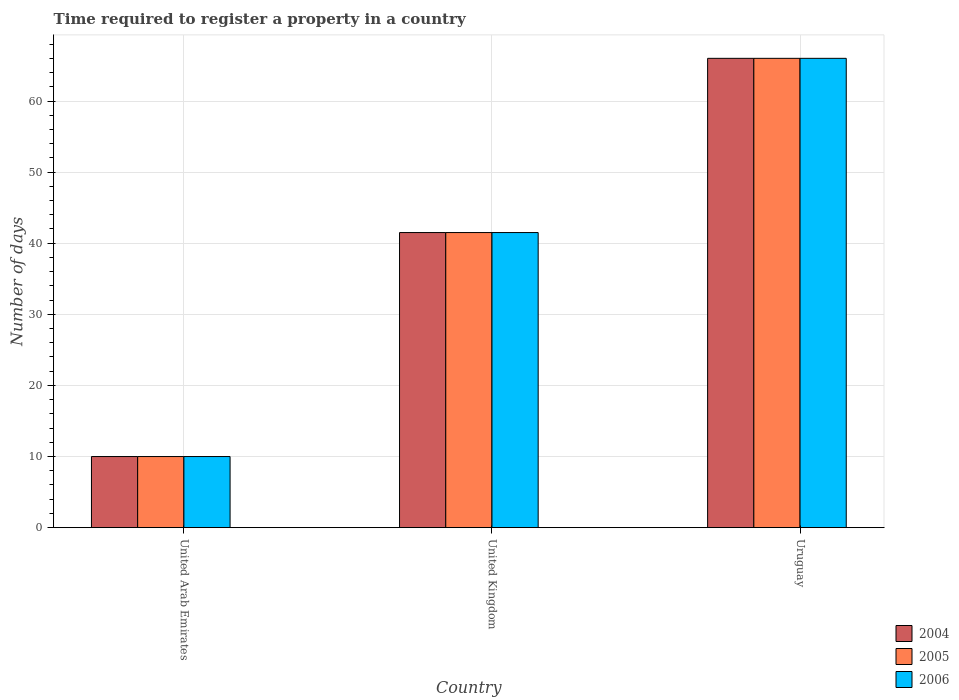How many groups of bars are there?
Ensure brevity in your answer.  3. Are the number of bars on each tick of the X-axis equal?
Provide a succinct answer. Yes. How many bars are there on the 3rd tick from the right?
Provide a succinct answer. 3. What is the label of the 1st group of bars from the left?
Your answer should be very brief. United Arab Emirates. What is the number of days required to register a property in 2006 in United Arab Emirates?
Provide a short and direct response. 10. Across all countries, what is the maximum number of days required to register a property in 2005?
Make the answer very short. 66. In which country was the number of days required to register a property in 2006 maximum?
Your answer should be compact. Uruguay. In which country was the number of days required to register a property in 2004 minimum?
Your response must be concise. United Arab Emirates. What is the total number of days required to register a property in 2004 in the graph?
Your answer should be compact. 117.5. What is the difference between the number of days required to register a property in 2004 in United Kingdom and that in Uruguay?
Your answer should be very brief. -24.5. What is the difference between the number of days required to register a property in 2004 in United Arab Emirates and the number of days required to register a property in 2006 in Uruguay?
Your answer should be compact. -56. What is the average number of days required to register a property in 2004 per country?
Keep it short and to the point. 39.17. What is the difference between the number of days required to register a property of/in 2006 and number of days required to register a property of/in 2005 in United Arab Emirates?
Provide a short and direct response. 0. In how many countries, is the number of days required to register a property in 2005 greater than 34 days?
Ensure brevity in your answer.  2. What is the ratio of the number of days required to register a property in 2004 in United Arab Emirates to that in Uruguay?
Give a very brief answer. 0.15. Is the number of days required to register a property in 2005 in United Arab Emirates less than that in United Kingdom?
Offer a terse response. Yes. What is the difference between the highest and the second highest number of days required to register a property in 2006?
Give a very brief answer. -24.5. What is the difference between the highest and the lowest number of days required to register a property in 2004?
Offer a terse response. 56. In how many countries, is the number of days required to register a property in 2004 greater than the average number of days required to register a property in 2004 taken over all countries?
Keep it short and to the point. 2. What does the 2nd bar from the right in United Arab Emirates represents?
Provide a succinct answer. 2005. Is it the case that in every country, the sum of the number of days required to register a property in 2004 and number of days required to register a property in 2005 is greater than the number of days required to register a property in 2006?
Provide a short and direct response. Yes. How many bars are there?
Provide a succinct answer. 9. What is the difference between two consecutive major ticks on the Y-axis?
Provide a short and direct response. 10. Does the graph contain grids?
Your answer should be compact. Yes. How many legend labels are there?
Your answer should be very brief. 3. How are the legend labels stacked?
Offer a very short reply. Vertical. What is the title of the graph?
Keep it short and to the point. Time required to register a property in a country. What is the label or title of the X-axis?
Ensure brevity in your answer.  Country. What is the label or title of the Y-axis?
Ensure brevity in your answer.  Number of days. What is the Number of days in 2004 in United Kingdom?
Give a very brief answer. 41.5. What is the Number of days of 2005 in United Kingdom?
Provide a short and direct response. 41.5. What is the Number of days in 2006 in United Kingdom?
Ensure brevity in your answer.  41.5. What is the Number of days in 2004 in Uruguay?
Provide a succinct answer. 66. What is the Number of days of 2005 in Uruguay?
Make the answer very short. 66. Across all countries, what is the maximum Number of days in 2005?
Offer a very short reply. 66. Across all countries, what is the minimum Number of days of 2006?
Give a very brief answer. 10. What is the total Number of days in 2004 in the graph?
Make the answer very short. 117.5. What is the total Number of days in 2005 in the graph?
Your response must be concise. 117.5. What is the total Number of days in 2006 in the graph?
Offer a terse response. 117.5. What is the difference between the Number of days of 2004 in United Arab Emirates and that in United Kingdom?
Your answer should be compact. -31.5. What is the difference between the Number of days of 2005 in United Arab Emirates and that in United Kingdom?
Your response must be concise. -31.5. What is the difference between the Number of days of 2006 in United Arab Emirates and that in United Kingdom?
Give a very brief answer. -31.5. What is the difference between the Number of days of 2004 in United Arab Emirates and that in Uruguay?
Offer a very short reply. -56. What is the difference between the Number of days in 2005 in United Arab Emirates and that in Uruguay?
Make the answer very short. -56. What is the difference between the Number of days of 2006 in United Arab Emirates and that in Uruguay?
Provide a short and direct response. -56. What is the difference between the Number of days in 2004 in United Kingdom and that in Uruguay?
Make the answer very short. -24.5. What is the difference between the Number of days of 2005 in United Kingdom and that in Uruguay?
Your answer should be compact. -24.5. What is the difference between the Number of days of 2006 in United Kingdom and that in Uruguay?
Provide a short and direct response. -24.5. What is the difference between the Number of days of 2004 in United Arab Emirates and the Number of days of 2005 in United Kingdom?
Make the answer very short. -31.5. What is the difference between the Number of days of 2004 in United Arab Emirates and the Number of days of 2006 in United Kingdom?
Offer a terse response. -31.5. What is the difference between the Number of days in 2005 in United Arab Emirates and the Number of days in 2006 in United Kingdom?
Your answer should be very brief. -31.5. What is the difference between the Number of days of 2004 in United Arab Emirates and the Number of days of 2005 in Uruguay?
Your response must be concise. -56. What is the difference between the Number of days of 2004 in United Arab Emirates and the Number of days of 2006 in Uruguay?
Offer a very short reply. -56. What is the difference between the Number of days in 2005 in United Arab Emirates and the Number of days in 2006 in Uruguay?
Give a very brief answer. -56. What is the difference between the Number of days of 2004 in United Kingdom and the Number of days of 2005 in Uruguay?
Provide a succinct answer. -24.5. What is the difference between the Number of days of 2004 in United Kingdom and the Number of days of 2006 in Uruguay?
Your answer should be very brief. -24.5. What is the difference between the Number of days of 2005 in United Kingdom and the Number of days of 2006 in Uruguay?
Offer a terse response. -24.5. What is the average Number of days in 2004 per country?
Offer a terse response. 39.17. What is the average Number of days in 2005 per country?
Your answer should be compact. 39.17. What is the average Number of days in 2006 per country?
Your response must be concise. 39.17. What is the difference between the Number of days of 2005 and Number of days of 2006 in United Arab Emirates?
Your answer should be very brief. 0. What is the difference between the Number of days of 2004 and Number of days of 2006 in United Kingdom?
Provide a succinct answer. 0. What is the difference between the Number of days in 2004 and Number of days in 2005 in Uruguay?
Keep it short and to the point. 0. What is the difference between the Number of days in 2005 and Number of days in 2006 in Uruguay?
Provide a short and direct response. 0. What is the ratio of the Number of days in 2004 in United Arab Emirates to that in United Kingdom?
Provide a succinct answer. 0.24. What is the ratio of the Number of days in 2005 in United Arab Emirates to that in United Kingdom?
Make the answer very short. 0.24. What is the ratio of the Number of days in 2006 in United Arab Emirates to that in United Kingdom?
Ensure brevity in your answer.  0.24. What is the ratio of the Number of days in 2004 in United Arab Emirates to that in Uruguay?
Give a very brief answer. 0.15. What is the ratio of the Number of days in 2005 in United Arab Emirates to that in Uruguay?
Offer a terse response. 0.15. What is the ratio of the Number of days in 2006 in United Arab Emirates to that in Uruguay?
Your answer should be very brief. 0.15. What is the ratio of the Number of days of 2004 in United Kingdom to that in Uruguay?
Offer a very short reply. 0.63. What is the ratio of the Number of days in 2005 in United Kingdom to that in Uruguay?
Your response must be concise. 0.63. What is the ratio of the Number of days in 2006 in United Kingdom to that in Uruguay?
Your response must be concise. 0.63. What is the difference between the highest and the second highest Number of days of 2004?
Ensure brevity in your answer.  24.5. What is the difference between the highest and the second highest Number of days in 2006?
Ensure brevity in your answer.  24.5. What is the difference between the highest and the lowest Number of days of 2005?
Your answer should be compact. 56. What is the difference between the highest and the lowest Number of days in 2006?
Make the answer very short. 56. 